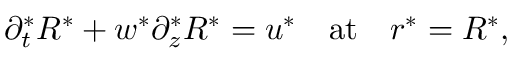<formula> <loc_0><loc_0><loc_500><loc_500>\partial _ { t } ^ { * } R ^ { * } + w ^ { * } \partial _ { z } ^ { * } R ^ { * } = u ^ { * } \quad a t \quad r ^ { * } = R ^ { * } ,</formula> 